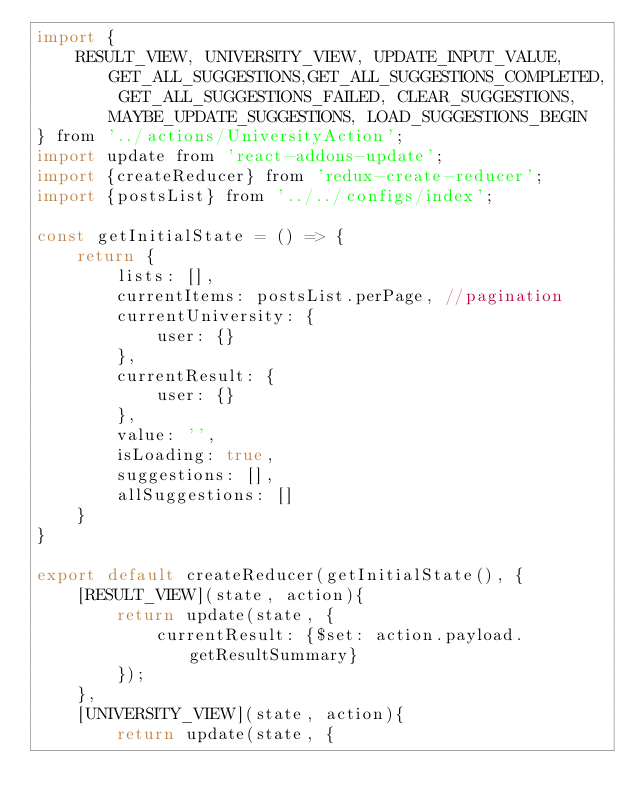Convert code to text. <code><loc_0><loc_0><loc_500><loc_500><_JavaScript_>import {
    RESULT_VIEW, UNIVERSITY_VIEW, UPDATE_INPUT_VALUE, GET_ALL_SUGGESTIONS,GET_ALL_SUGGESTIONS_COMPLETED, GET_ALL_SUGGESTIONS_FAILED, CLEAR_SUGGESTIONS, MAYBE_UPDATE_SUGGESTIONS, LOAD_SUGGESTIONS_BEGIN
} from '../actions/UniversityAction';
import update from 'react-addons-update';
import {createReducer} from 'redux-create-reducer';
import {postsList} from '../../configs/index';

const getInitialState = () => {
    return {
        lists: [],
        currentItems: postsList.perPage, //pagination
        currentUniversity: {
            user: {}
        },
        currentResult: {
            user: {}
        },
        value: '',
        isLoading: true,
        suggestions: [],
        allSuggestions: []
    }
}

export default createReducer(getInitialState(), {
    [RESULT_VIEW](state, action){
        return update(state, {
            currentResult: {$set: action.payload.getResultSummary}
        });
    },
    [UNIVERSITY_VIEW](state, action){
        return update(state, {</code> 